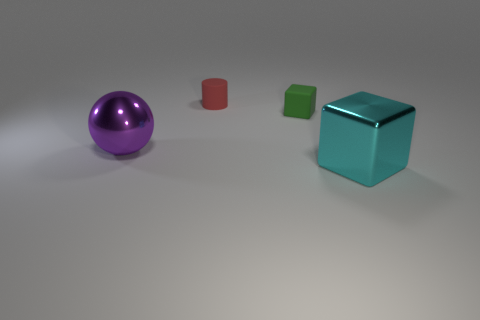What number of shiny things have the same shape as the green matte thing?
Offer a terse response. 1. What is the size of the object on the left side of the rubber thing left of the tiny green thing?
Your answer should be very brief. Large. What material is the other thing that is the same shape as the cyan object?
Keep it short and to the point. Rubber. How many shiny spheres have the same size as the rubber cylinder?
Your response must be concise. 0. Is the ball the same size as the red matte thing?
Your response must be concise. No. There is a thing that is in front of the tiny green rubber cube and right of the large purple shiny sphere; what size is it?
Your answer should be very brief. Large. Is the number of green objects that are behind the metallic cube greater than the number of tiny objects on the left side of the green rubber block?
Offer a terse response. No. What is the color of the other object that is the same shape as the green object?
Your answer should be very brief. Cyan. What number of tiny purple cylinders are there?
Offer a terse response. 0. Are the tiny thing that is in front of the tiny red rubber object and the small cylinder made of the same material?
Offer a very short reply. Yes. 